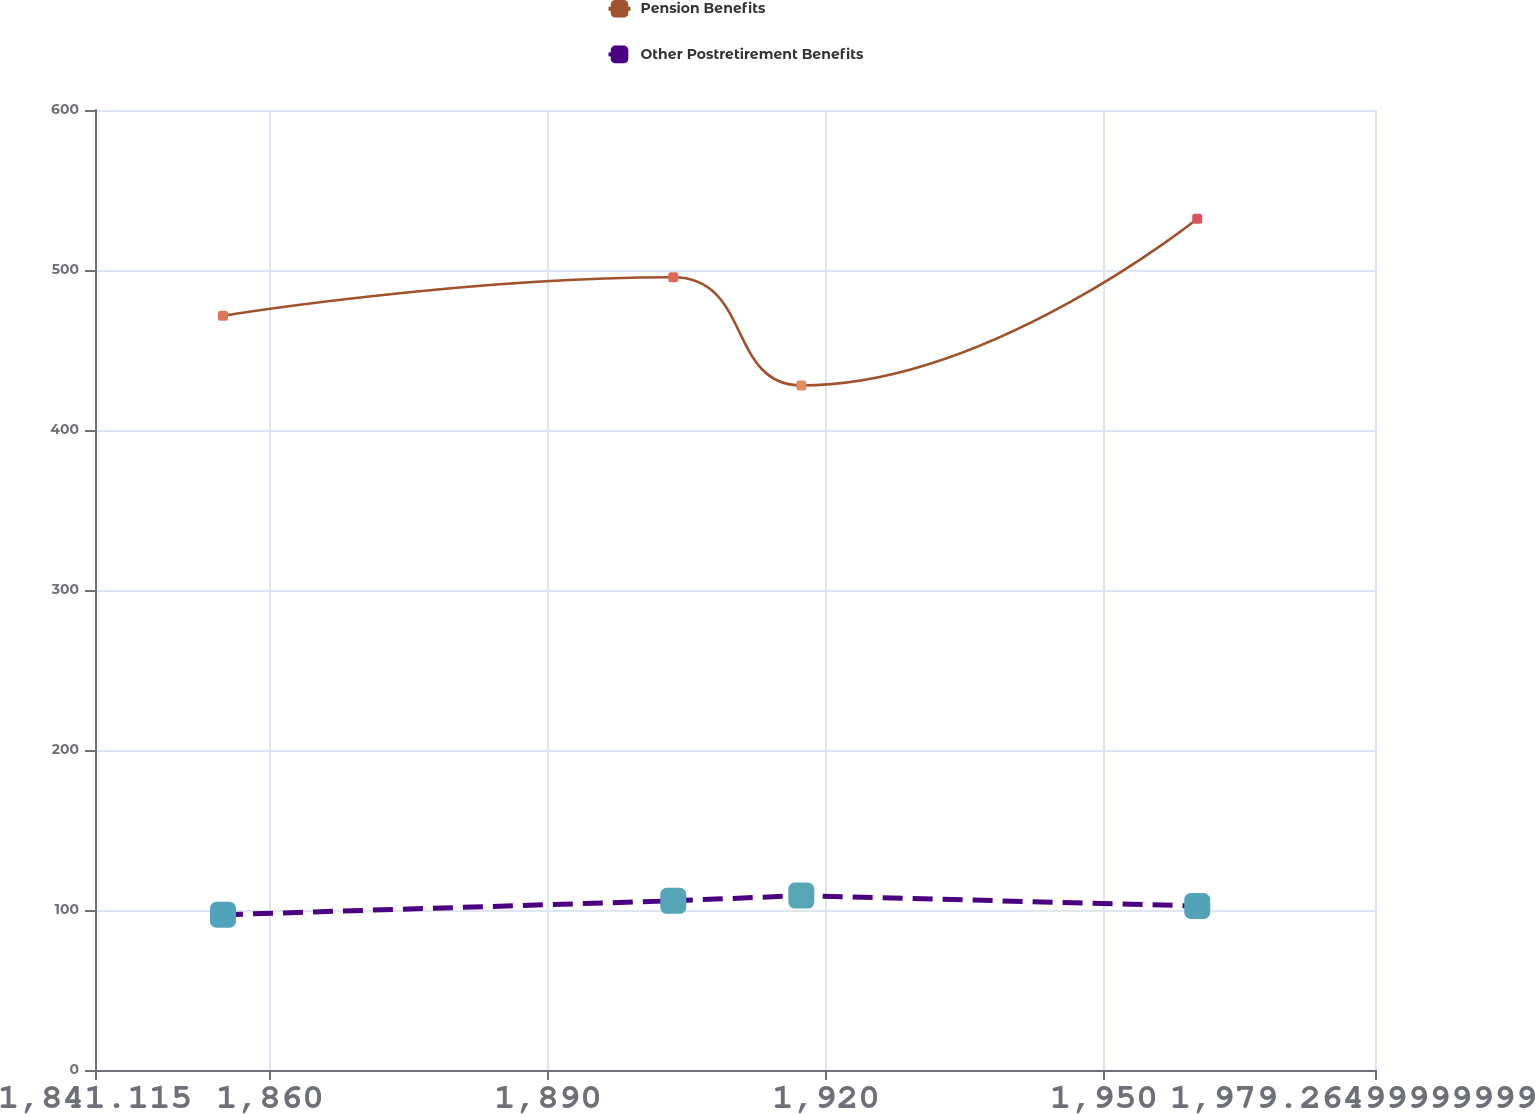<chart> <loc_0><loc_0><loc_500><loc_500><line_chart><ecel><fcel>Pension Benefits<fcel>Other Postretirement Benefits<nl><fcel>1854.93<fcel>471.34<fcel>97.03<nl><fcel>1903.53<fcel>495.45<fcel>105.75<nl><fcel>1917.35<fcel>427.85<fcel>109.01<nl><fcel>1960.08<fcel>532.01<fcel>102.49<nl><fcel>1993.08<fcel>542.63<fcel>129.66<nl></chart> 